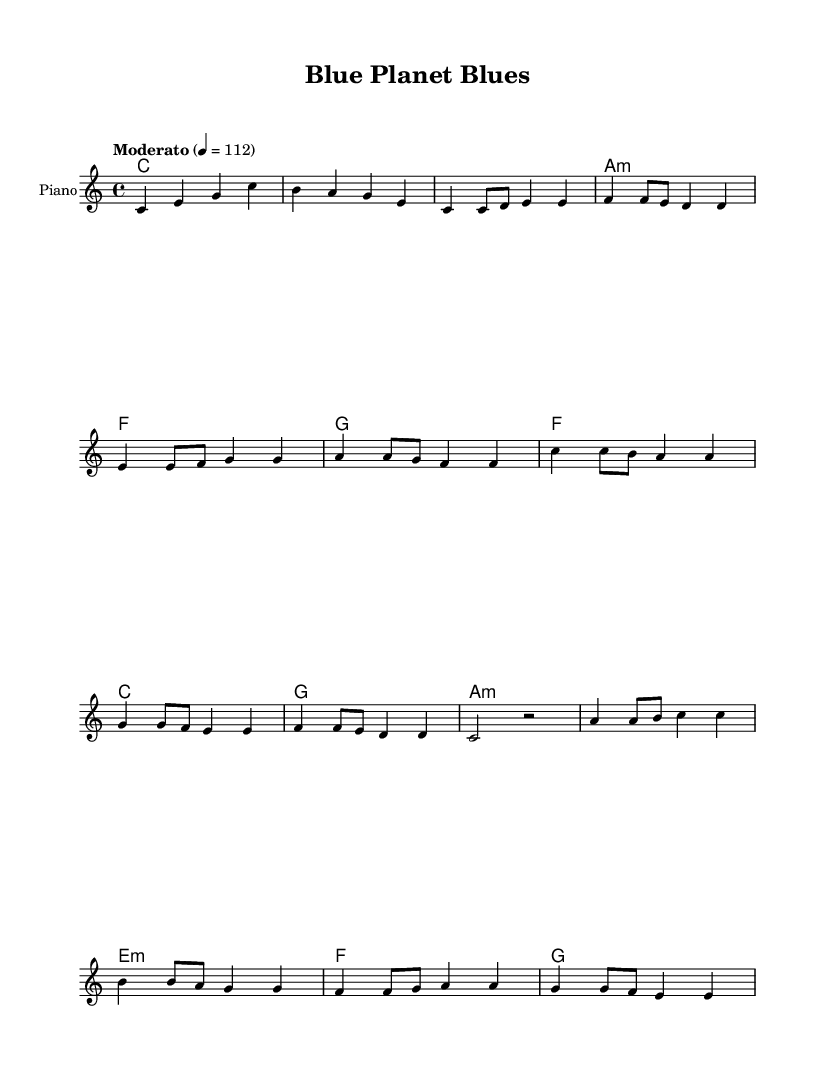What is the key signature of this music? The key signature is indicated at the beginning of the score and is shown as C major, characterized by no sharps or flats.
Answer: C major What is the time signature? The time signature is shown at the beginning and is written as 4/4, meaning there are four beats in each measure and the quarter note gets one beat.
Answer: 4/4 What is the tempo marking? The tempo marking is located at the beginning of the score, stating "Moderato" with a tempo of quarter note equals 112 beats per minute.
Answer: Moderato, 112 How many measures are there in the chorus section? By counting the individual measures in the chorus section, which consists of the lyrical lines associated with it, there are a total of four measures.
Answer: 4 What is the overall theme of the song based on the lyrics? The theme can be inferred from the lyrics throughout the song, which emphasize ocean conservation and the urgency to protect marine life, as seen in the repeated call to action regarding sea protection.
Answer: Ocean conservation What type of musical form is used in this piece? The music exhibits a common pop song structure consisting of verses, a chorus, and a bridge, which is typical for pop music and helps deliver the song's message effectively.
Answer: Verse-Chorus-Bridge 